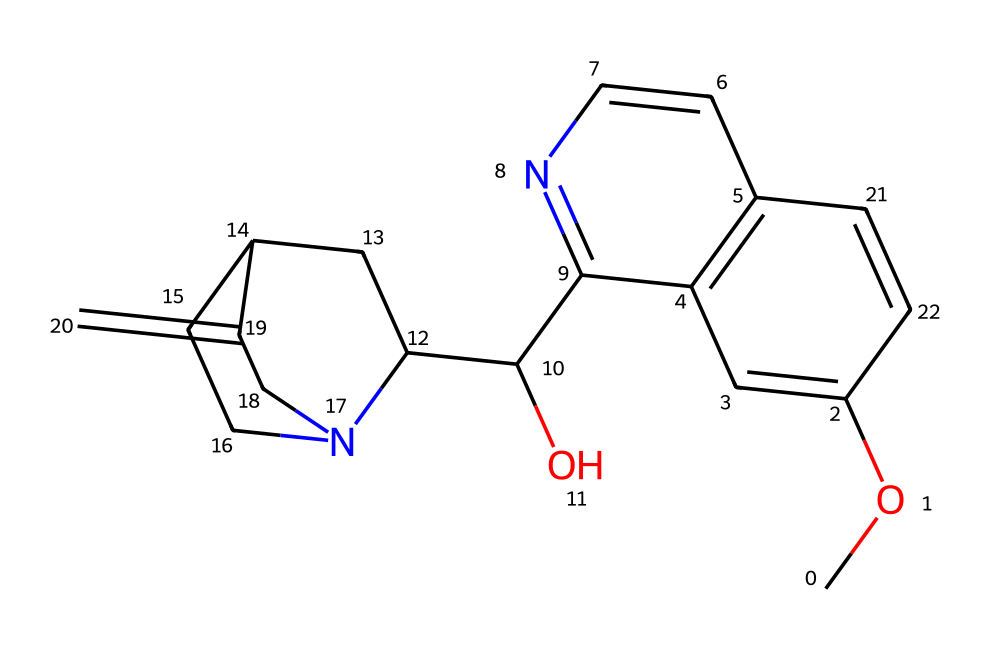What is the main alkaloid found in tonic water? The chemical structure provided corresponds to quinine, which is known to be the primary alkaloid present in tonic water.
Answer: quinine How many nitrogen atoms are present in the chemical structure? By examining the structure, we can count the nitrogen atoms denoted by the blue colored symbols in the representation. There are two nitrogen atoms visible in the structure.
Answer: two What is the significance of the hydroxyl group in this chemical? The hydroxyl group, indicated by the –OH section in the structure, is important for its solubility in water and contributes to its bitter taste.
Answer: solubility What is the total number of rings in this chemical structure? Analyzing the structure reveals that there are multiple cyclic arrangements. In total, there are four rings present in the compound.
Answer: four Which element predominantly provides the bitterness in quinine? The bitterness in quinine can be attributed to the presence of the nitrogen atoms in the structure, which are characteristic of alkaloids known for their bitter taste.
Answer: nitrogen What functional group features prominently in alkaloids like quinine? Alkaloids like quinine often contain nitrogen heterocycles, which refer to rings containing nitrogen and are pivotal for their biological activity. In this structure, the heterocyclic properties are displayed in multiple rings.
Answer: nitrogen heterocycles 